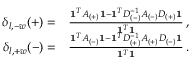<formula> <loc_0><loc_0><loc_500><loc_500>\begin{array} { r l } { \delta _ { l , - w } ( + ) = } & { \frac { 1 ^ { T } A _ { ( + ) } 1 - 1 ^ { T } D _ { ( - ) } ^ { - 1 } A _ { ( - ) } D _ { ( + ) } 1 } { 1 ^ { T } 1 } \, , } \\ { \delta _ { l , + w } ( - ) = } & { \frac { 1 ^ { T } A _ { ( - ) } 1 - 1 ^ { T } D _ { ( + ) } ^ { - 1 } A _ { ( + ) } D _ { ( - ) } 1 } { 1 ^ { T } 1 } \, . } \end{array}</formula> 